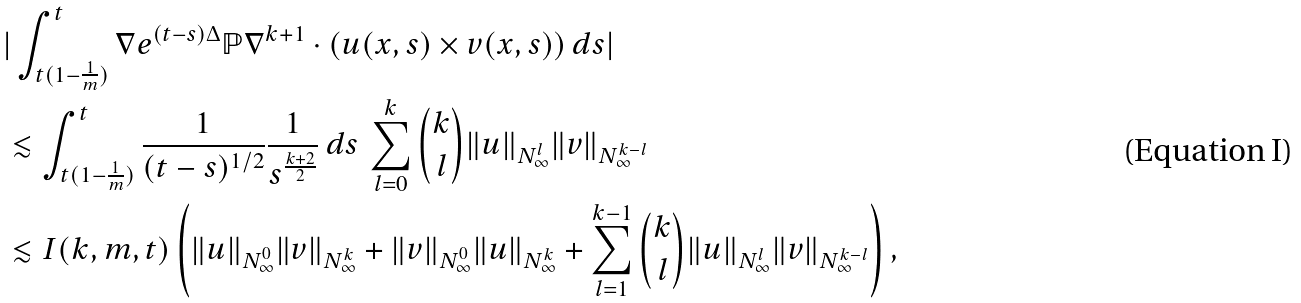Convert formula to latex. <formula><loc_0><loc_0><loc_500><loc_500>& | \int _ { t ( 1 - \frac { 1 } { m } ) } ^ { t } \nabla e ^ { ( t - s ) \Delta } { \mathbb { P } } \nabla ^ { k + 1 } \cdot ( u ( x , s ) \times v ( x , s ) ) \, d s | \\ & \lesssim \int _ { t ( 1 - \frac { 1 } { m } ) } ^ { t } \frac { 1 } { ( t - s ) ^ { 1 / 2 } } \frac { 1 } { s ^ { \frac { k + 2 } { 2 } } } \, d s \, \sum _ { l = 0 } ^ { k } \binom { k } { l } \| u \| _ { N ^ { l } _ { \infty } } \| v \| _ { N ^ { k - l } _ { \infty } } \\ & \lesssim I ( k , m , t ) \left ( \| u \| _ { N ^ { 0 } _ { \infty } } \| v \| _ { N ^ { k } _ { \infty } } + \| v \| _ { N ^ { 0 } _ { \infty } } \| u \| _ { N ^ { k } _ { \infty } } + \sum _ { l = 1 } ^ { k - 1 } \binom { k } { l } \| u \| _ { N ^ { l } _ { \infty } } \| v \| _ { N ^ { k - l } _ { \infty } } \right ) ,</formula> 